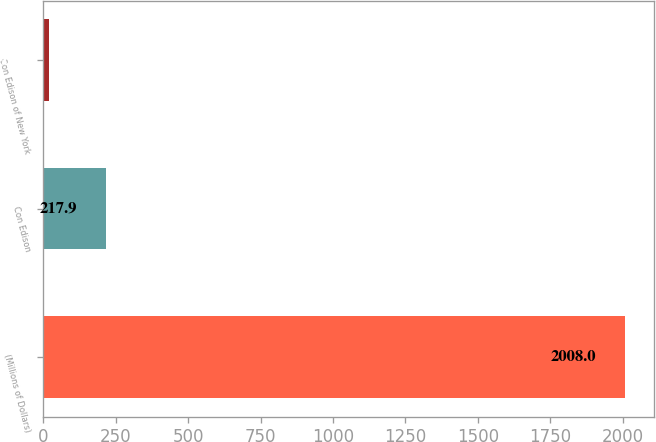<chart> <loc_0><loc_0><loc_500><loc_500><bar_chart><fcel>(Millions of Dollars)<fcel>Con Edison<fcel>Con Edison of New York<nl><fcel>2008<fcel>217.9<fcel>19<nl></chart> 